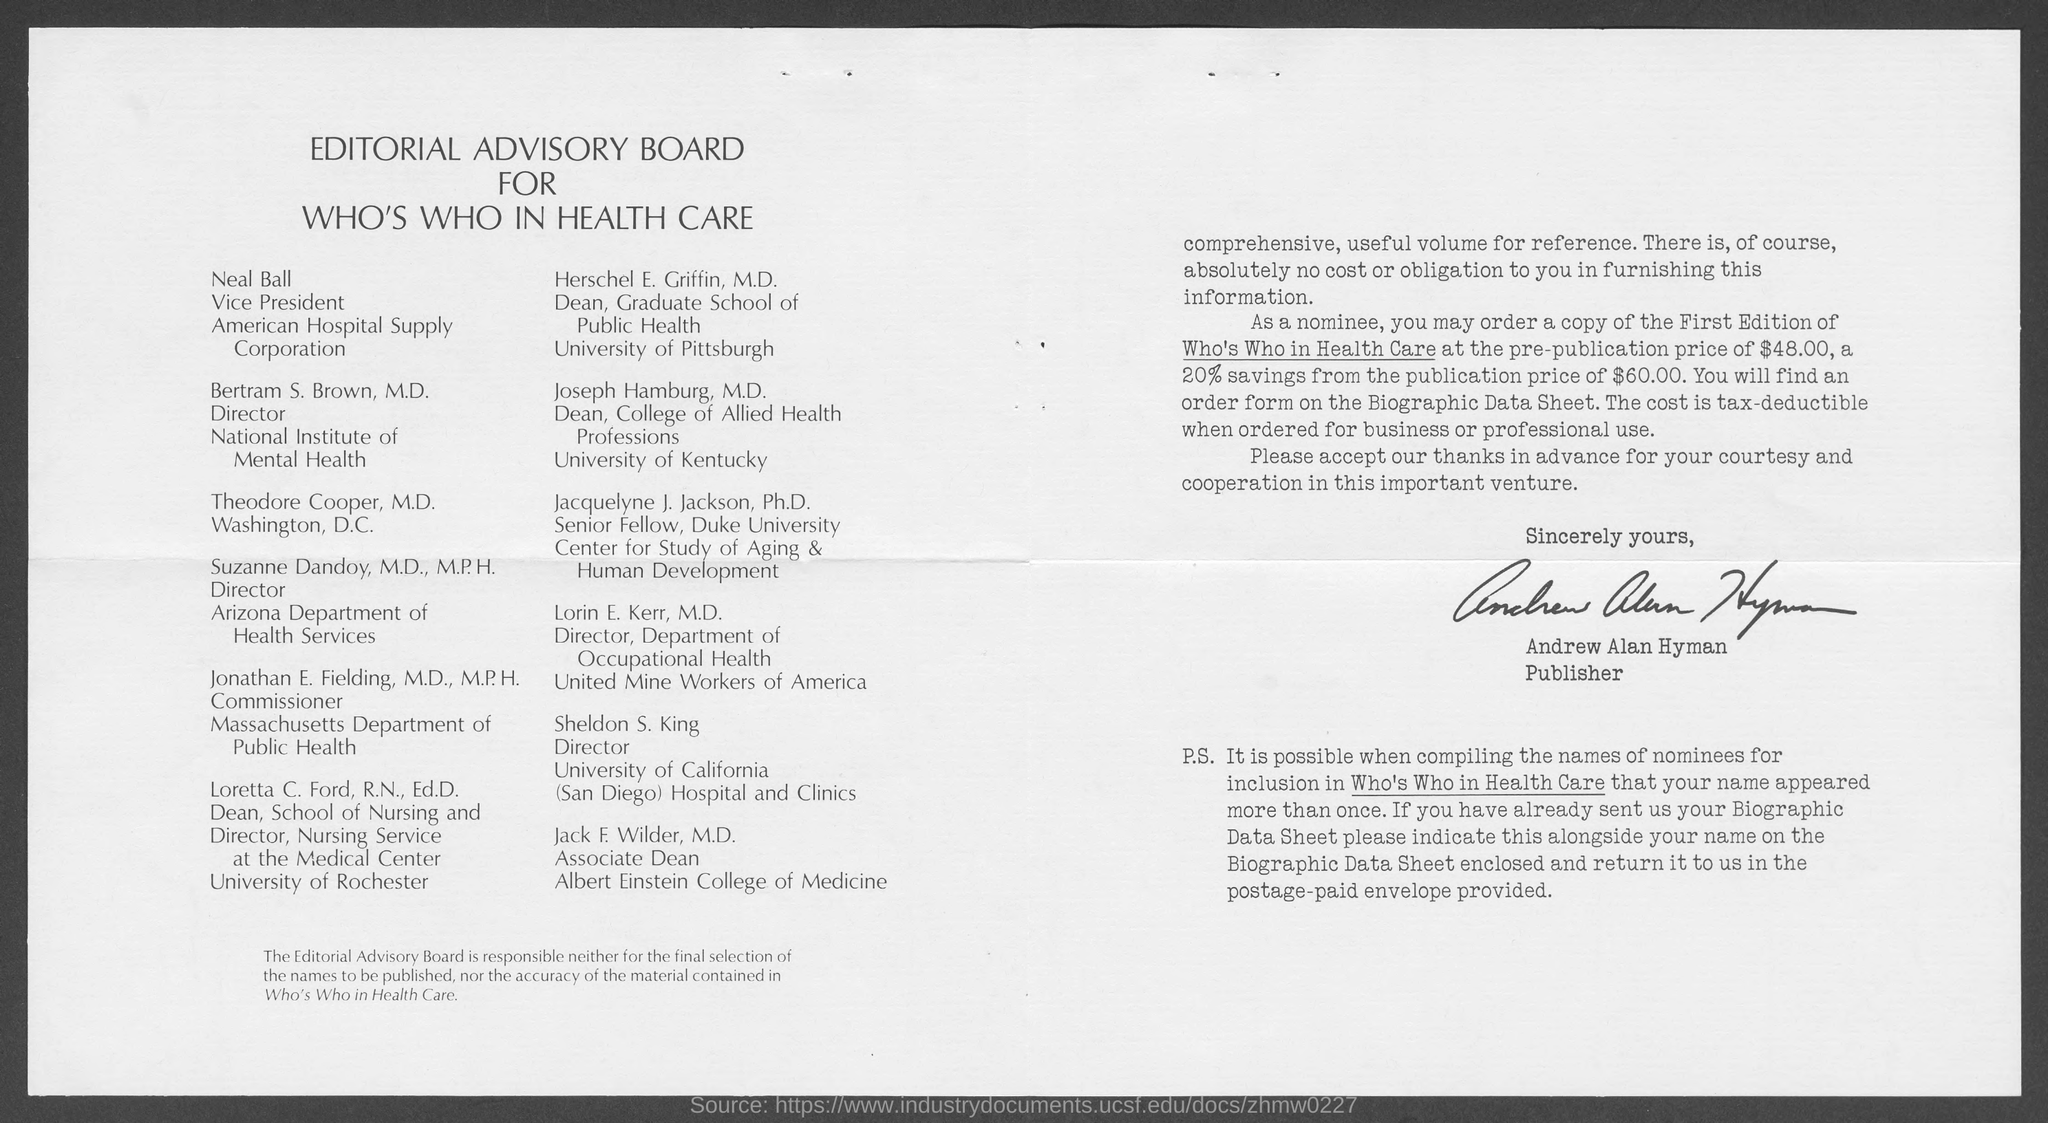Who is the publisher?
Your response must be concise. Andrew Alan Hyman. Who is Neal Ball?
Ensure brevity in your answer.  Vice president american hospital Supply Corporation. 